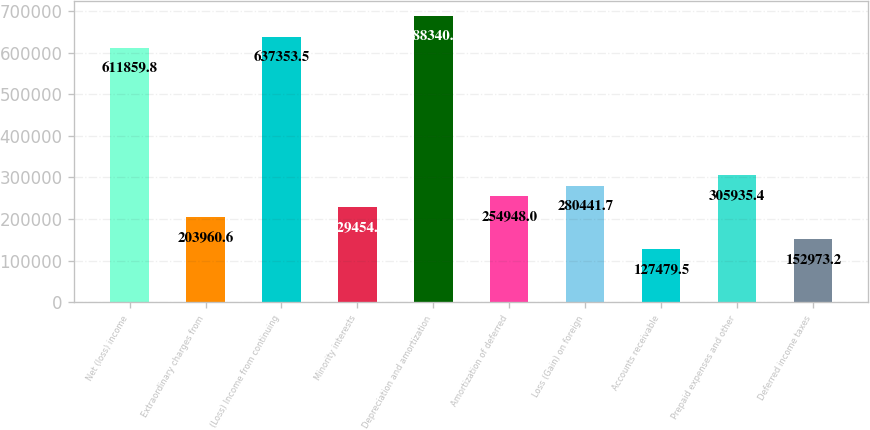<chart> <loc_0><loc_0><loc_500><loc_500><bar_chart><fcel>Net (loss) income<fcel>Extraordinary charges from<fcel>(Loss) Income from continuing<fcel>Minority interests<fcel>Depreciation and amortization<fcel>Amortization of deferred<fcel>Loss (Gain) on foreign<fcel>Accounts receivable<fcel>Prepaid expenses and other<fcel>Deferred income taxes<nl><fcel>611860<fcel>203961<fcel>637354<fcel>229454<fcel>688341<fcel>254948<fcel>280442<fcel>127480<fcel>305935<fcel>152973<nl></chart> 